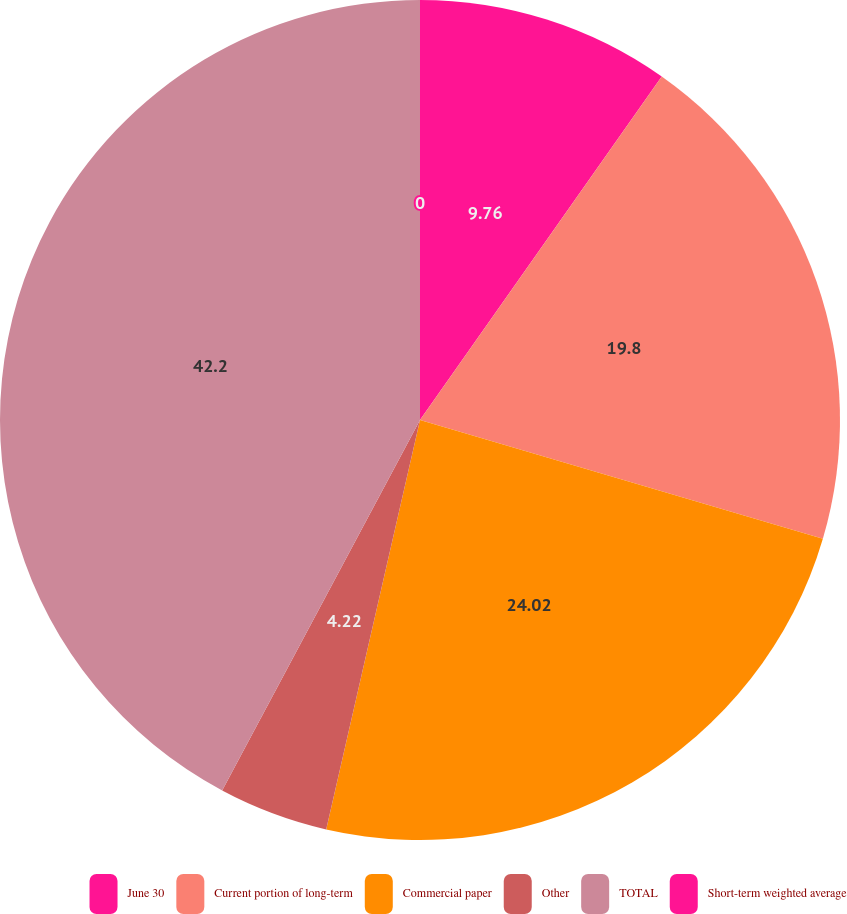Convert chart. <chart><loc_0><loc_0><loc_500><loc_500><pie_chart><fcel>June 30<fcel>Current portion of long-term<fcel>Commercial paper<fcel>Other<fcel>TOTAL<fcel>Short-term weighted average<nl><fcel>9.76%<fcel>19.8%<fcel>24.02%<fcel>4.22%<fcel>42.19%<fcel>0.0%<nl></chart> 